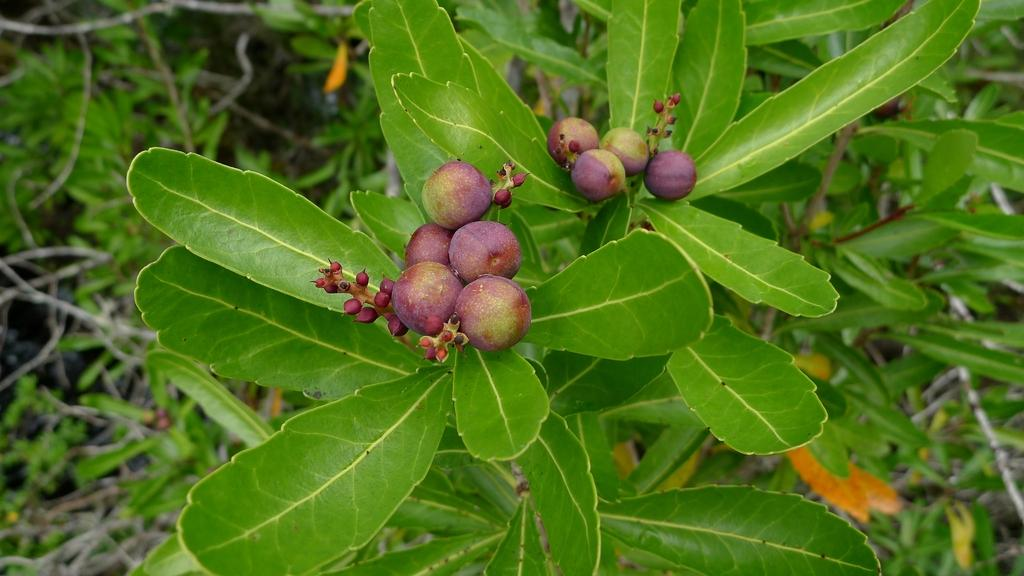What colors are the fruits in the image? The fruits in the image are purple and green. What else can be seen in the image besides the fruits? There are plants in the image. Can you describe the background of the image? The background of the image is partially blurred. What verse is being recited by the thing in the image? There is no thing or verse present in the image; it features fruits and plants. 